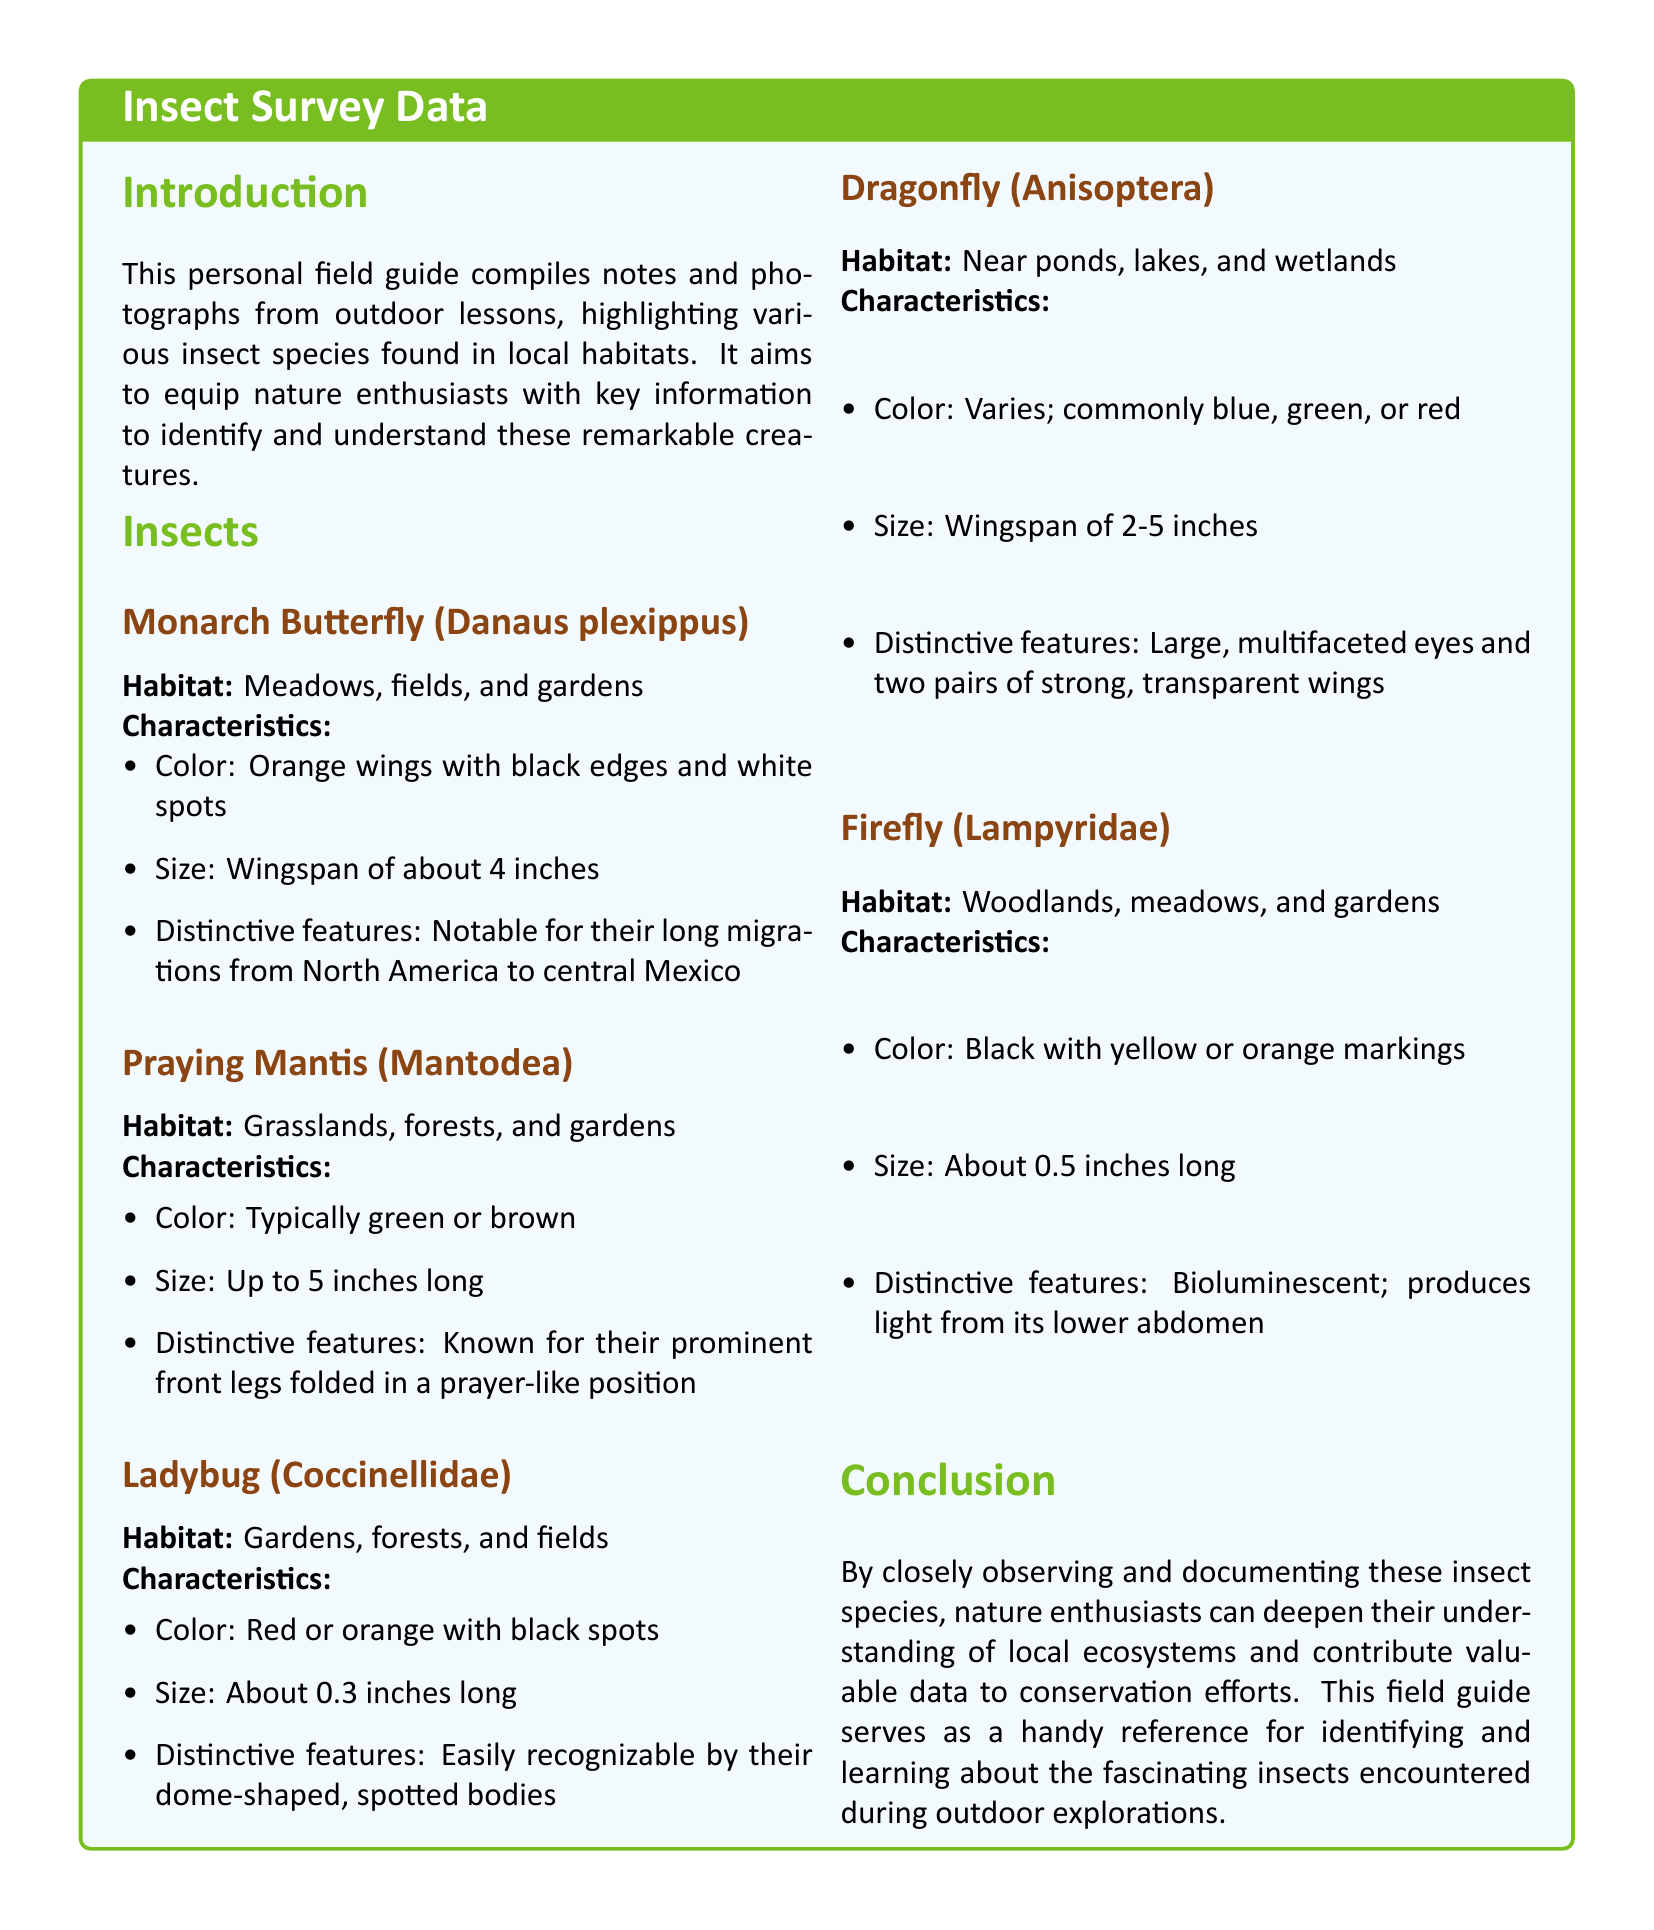What is the wingspan of the Monarch Butterfly? The wingspan of the Monarch Butterfly is mentioned in the characteristics section of the document.
Answer: 4 inches What color are the wings of the Praying Mantis? The document specifies the typical color of the Praying Mantis in its characteristics.
Answer: Green or brown What is the size of a Ladybug? The size of a Ladybug is listed in the characteristics section of the document.
Answer: About 0.3 inches long Which insect is known for producing light from its lower abdomen? The document describes the distinctive features of the Firefly, which includes its ability to produce light.
Answer: Firefly In which habitats can Dragonflies typically be found? The document mentions the habitat where Dragonflies are commonly found.
Answer: Near ponds, lakes, and wetlands How many inches can a Dragonfly's wingspan range from? The document provides the range of the wingspan for Dragonflies in its characteristics.
Answer: 2-5 inches What color are Ladybugs typically? The document specifies the typical colors of Ladybugs in the characteristics section.
Answer: Red or orange with black spots What is a distinctive feature of the Monarch Butterfly? The document highlights distinctive features in the characteristics of the Monarch Butterfly.
Answer: Long migrations from North America to central Mexico 